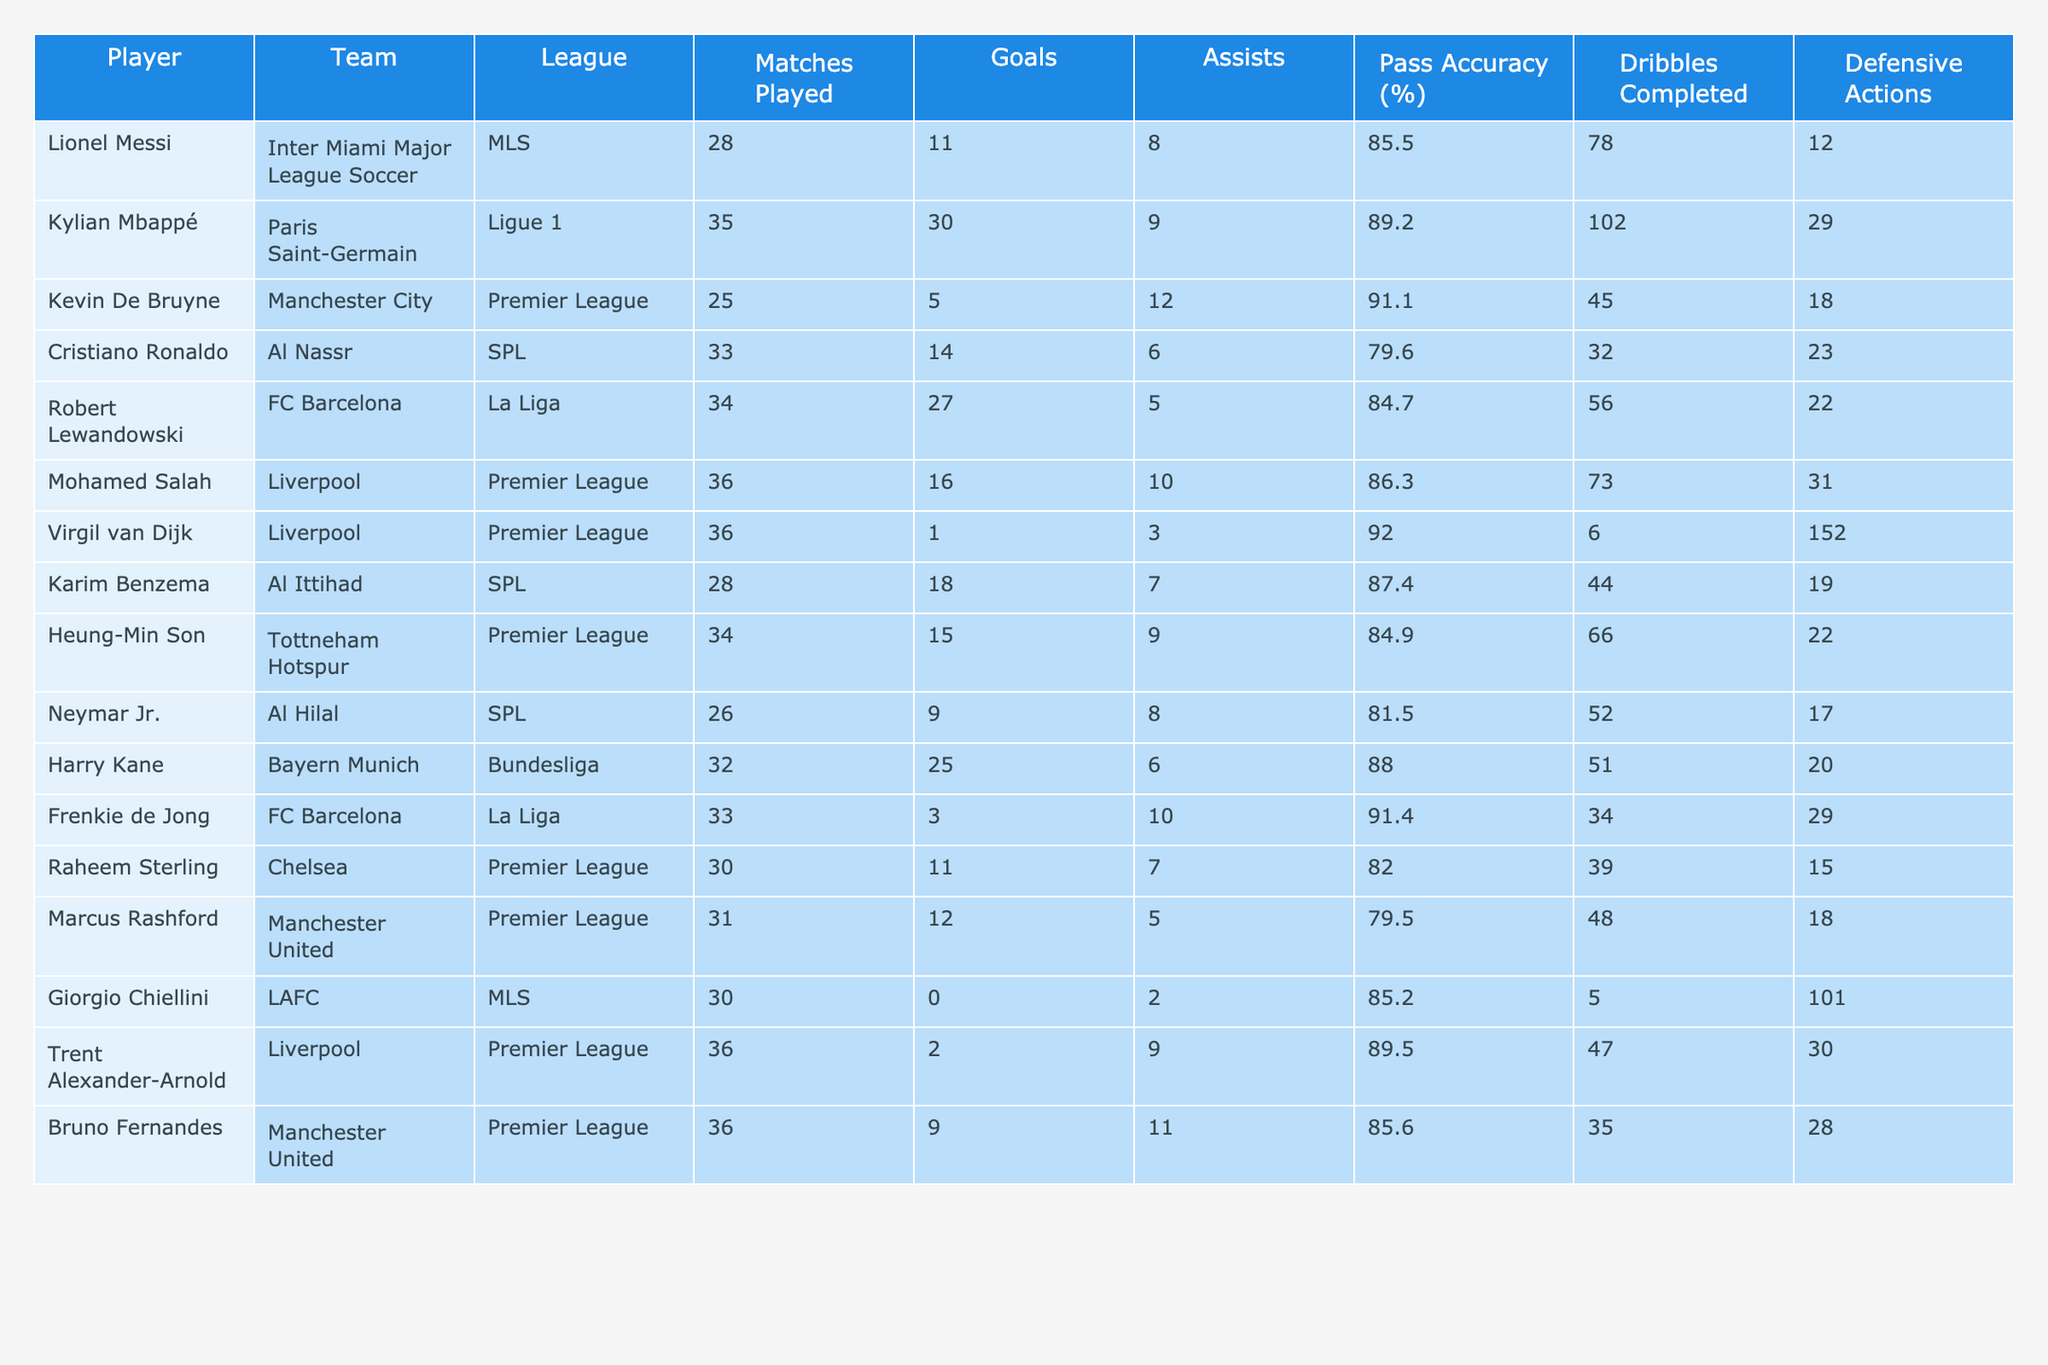What is the total number of goals scored by players from the SPL? The players from the SPL are Cristiano Ronaldo, Karim Benzema, and Neymar Jr., who scored 14, 18, and 9 goals respectively. Summing these gives 14 + 18 + 9 = 41.
Answer: 41 Which player has the highest pass accuracy? By examining the table, the player with the highest pass accuracy is Kevin De Bruyne at 91.1%.
Answer: 91.1% How many assists did Mohamed Salah record? The table shows that Mohamed Salah recorded 10 assists.
Answer: 10 Is Virgil van Dijk one of the players who scored more than 5 goals? The table lists Virgil van Dijk as having scored only 1 goal, which is not more than 5.
Answer: No What is the average number of goals scored by players in the Premier League? The players in the Premier League are Kevin De Bruyne (5), Mohamed Salah (16), Heung-Min Son (15), Raheem Sterling (11), Marcus Rashford (12), and Bruno Fernandes (9). Summing these goals gives 5 + 16 + 15 + 11 + 12 + 9 = 68, and averaging over 6 players gives 68/6 ≈ 11.33.
Answer: 11.33 Which player completed the most dribbles, and how many did they complete? Kylian Mbappé completed the most dribbles at 102, which is the highest value noted in the table.
Answer: Kylian Mbappé, 102 How many defensive actions did Virgil van Dijk perform compared to Raheem Sterling? Virgil van Dijk performed 152 defensive actions, while Raheem Sterling performed 15. The difference is 152 - 15 = 137.
Answer: 137 Which league has the player with the most goals, and how many goals did he score? Robert Lewandowski from La Liga scored the most goals at 27.
Answer: La Liga, 27 If we consider only players who scored over 15 goals, how many assists did they provide in total? The players who scored over 15 goals are Kylian Mbappé (9 assists), Robert Lewandowski (5 assists), and Harry Kane (6 assists). Summing these gives 9 + 5 + 6 = 20 assists.
Answer: 20 Does Neymar Jr. have more assists than Raheem Sterling? Neymar Jr. has 8 assists while Raheem Sterling has 7. Therefore, Neymar has more assists than Raheem.
Answer: Yes What percentage of matches did Lionel Messi score in? Lionel Messi scored 11 goals in 28 matches. To find the percentage, we calculate (11/28) * 100, which is approximately 39.29%.
Answer: 39.29% 